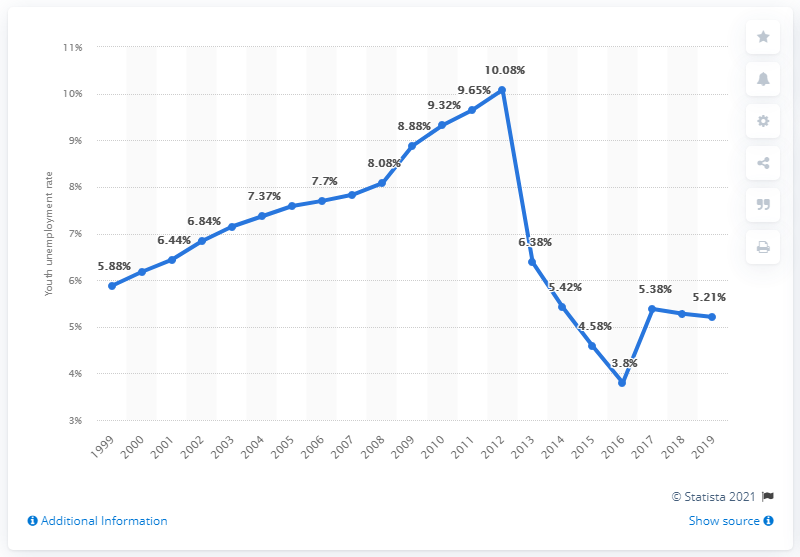Give some essential details in this illustration. In 2019, the youth unemployment rate in Cote d'Ivoire was 5.21%. 